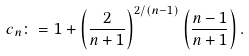Convert formula to latex. <formula><loc_0><loc_0><loc_500><loc_500>c _ { n } \colon = 1 + \left ( \frac { 2 } { n + 1 } \right ) ^ { 2 / ( n - 1 ) } \left ( \frac { n - 1 } { n + 1 } \right ) .</formula> 